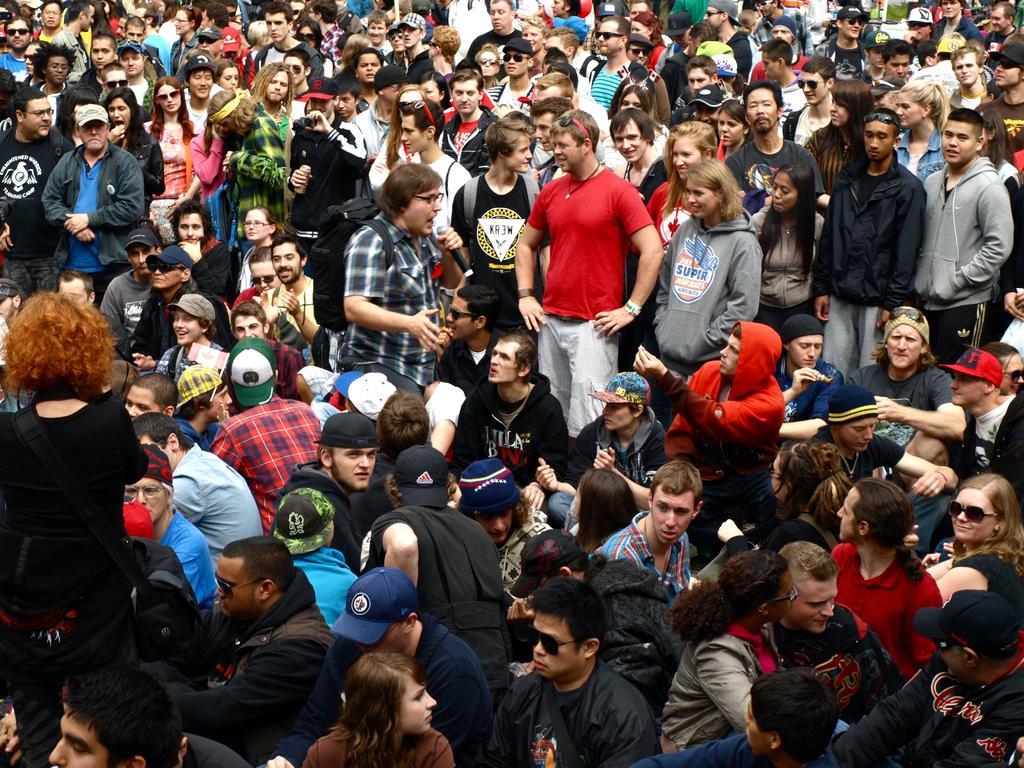Please provide a concise description of this image. In this image a group of persons standing as we can see on the top of this image and there is a group of persons sitting on the bottom of this image. 